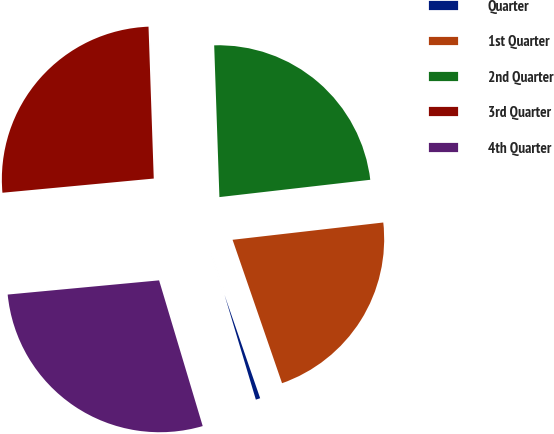Convert chart to OTSL. <chart><loc_0><loc_0><loc_500><loc_500><pie_chart><fcel>Quarter<fcel>1st Quarter<fcel>2nd Quarter<fcel>3rd Quarter<fcel>4th Quarter<nl><fcel>0.66%<fcel>21.53%<fcel>23.73%<fcel>25.94%<fcel>28.14%<nl></chart> 